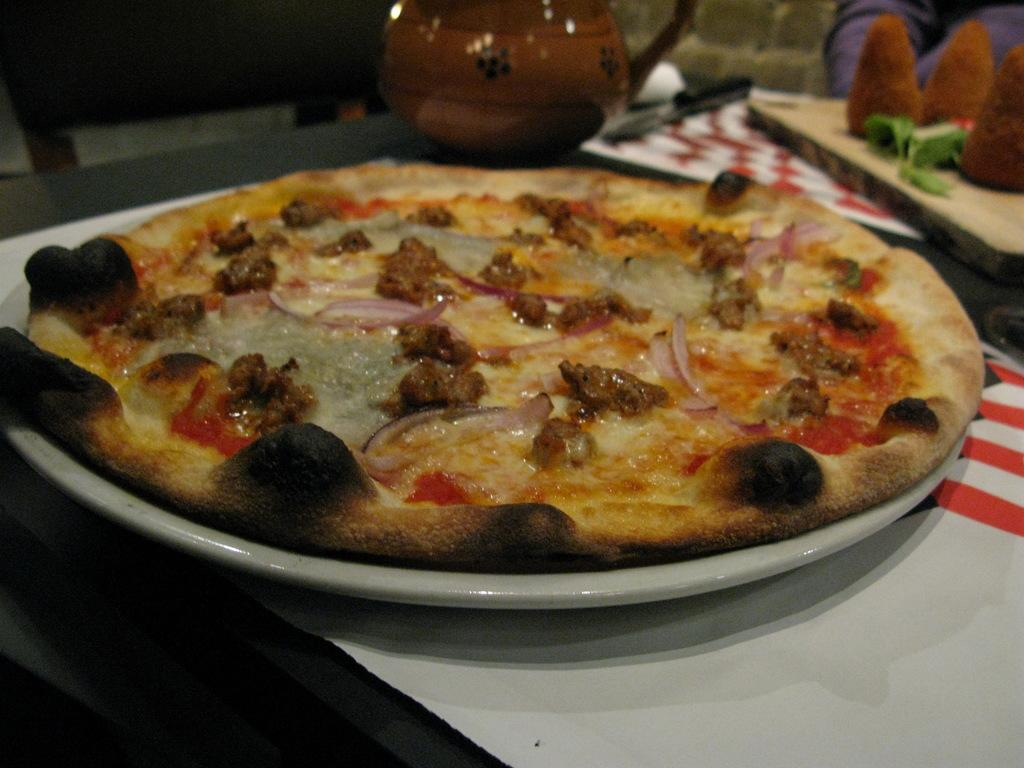What is located in the foreground of the image? There is a table in the foreground of the image. What is on the table? A pizza plate, a kettle, and a knife are on the table. What type of food is present on the table? Food items are on the table. Where might this image have been taken? The image is likely taken in a room. What type of bomb is visible on the table in the image? There is no bomb present in the image; the table contains a pizza plate, a kettle, a knife, and food items. Can you hear the daughter's laughter in the image? There is no daughter or any sound mentioned in the image; it is a still photograph. 